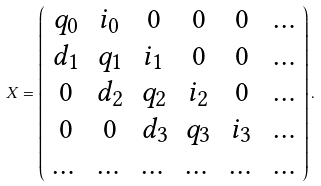Convert formula to latex. <formula><loc_0><loc_0><loc_500><loc_500>X = \left ( \begin{array} { c c c c c c } q _ { 0 } & i _ { 0 } & 0 & 0 & 0 & \dots \\ d _ { 1 } & q _ { 1 } & i _ { 1 } & 0 & 0 & \dots \\ 0 & d _ { 2 } & q _ { 2 } & i _ { 2 } & 0 & \dots \\ 0 & 0 & d _ { 3 } & q _ { 3 } & i _ { 3 } & \dots \\ \dots & \dots & \dots & \dots & \dots & \dots \end{array} \right ) .</formula> 